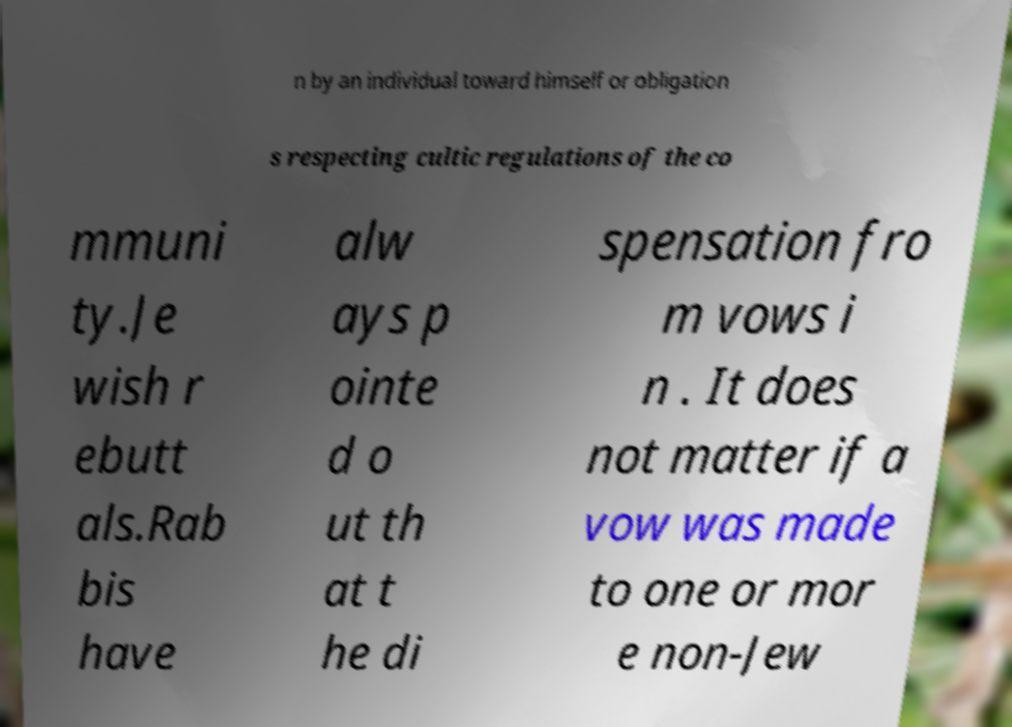For documentation purposes, I need the text within this image transcribed. Could you provide that? n by an individual toward himself or obligation s respecting cultic regulations of the co mmuni ty.Je wish r ebutt als.Rab bis have alw ays p ointe d o ut th at t he di spensation fro m vows i n . It does not matter if a vow was made to one or mor e non-Jew 